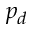Convert formula to latex. <formula><loc_0><loc_0><loc_500><loc_500>p _ { d }</formula> 